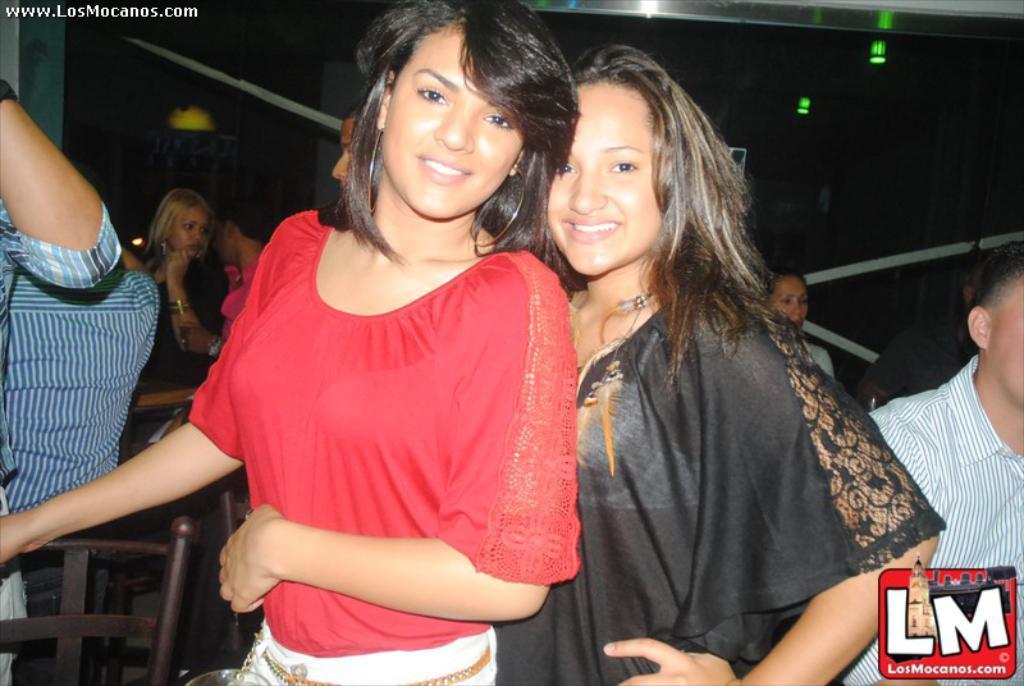How would you summarize this image in a sentence or two? In this picture there are two women who are standing and smiling. There is a man. There are few people at the background. There is a light on the roof. 